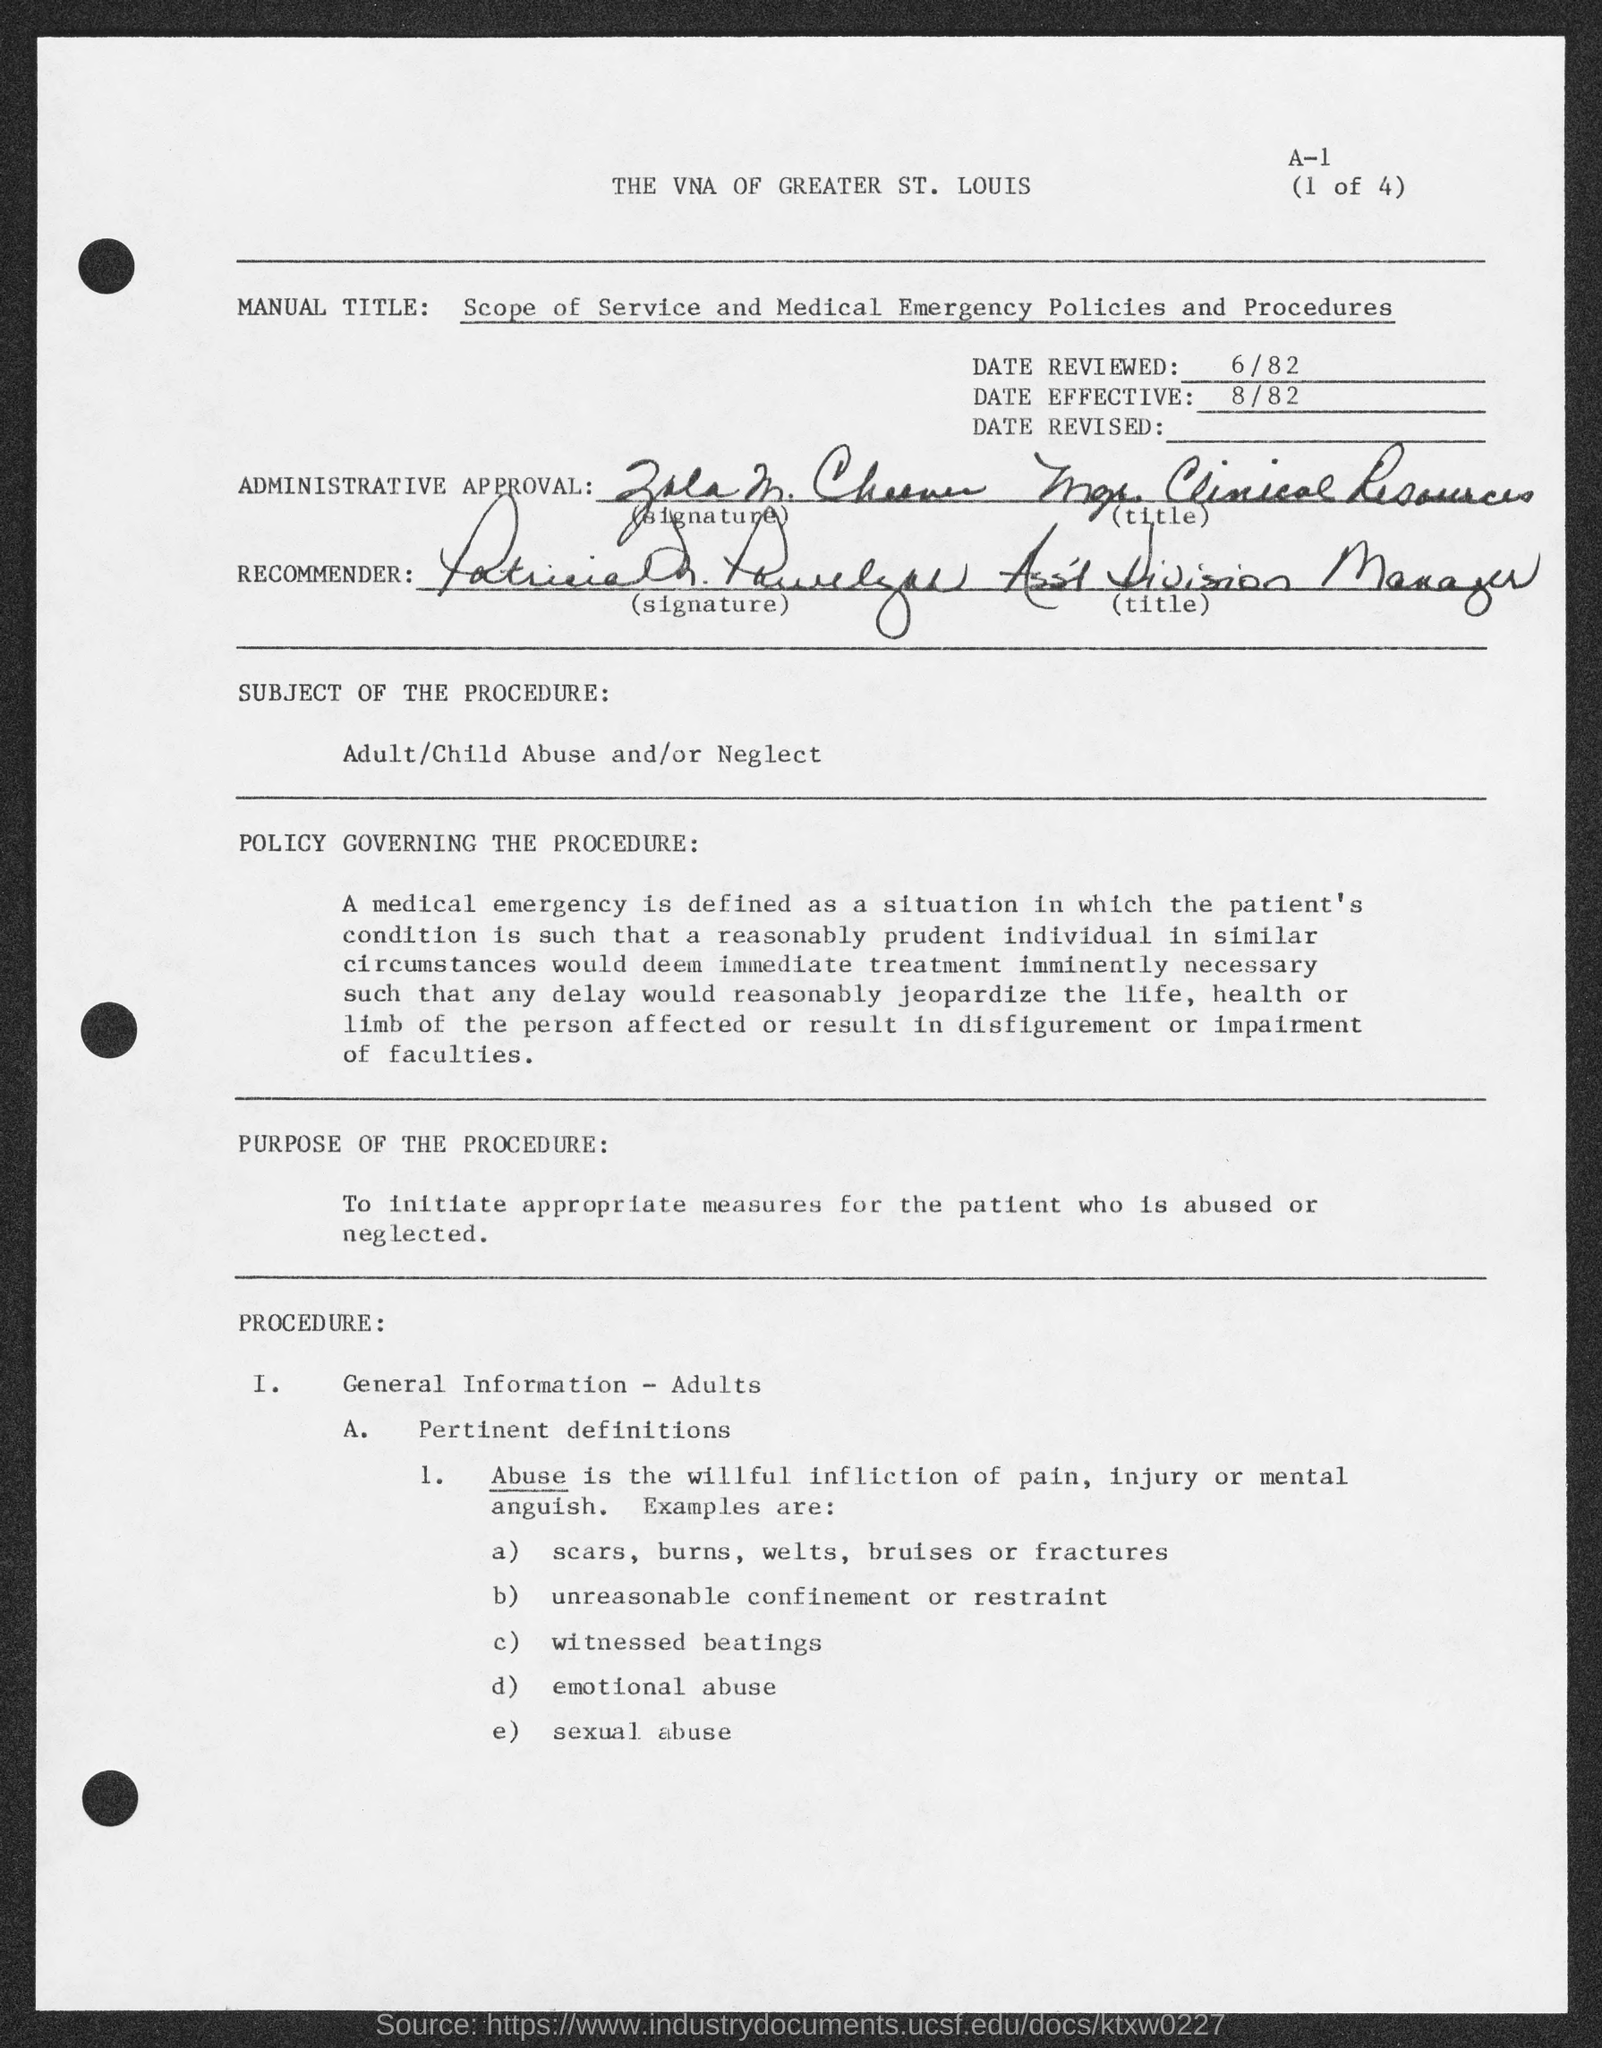What policy does this document refer to? The document refers to a policy governing the procedure for handling cases of adult/child abuse and/or neglect, as stated under the 'POLICY GOVERNING THE PROCEDURE' section. What are some examples of abuse listed in this document? Examples of abuse listed in the document include scars, burns, welts, bruises or fractures, unreasonable confinement or restraint, witnessed beatings, emotional abuse, and sexual abuse. 